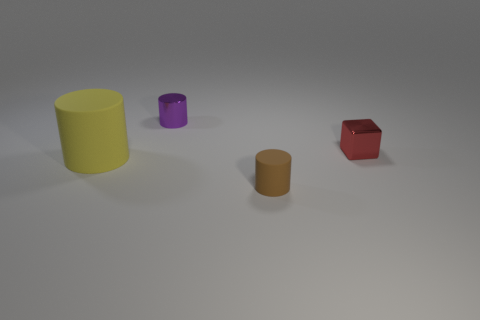Are there any other things that have the same size as the yellow matte cylinder?
Your response must be concise. No. There is a shiny object that is left of the rubber cylinder on the right side of the purple shiny cylinder; what color is it?
Your answer should be very brief. Purple. Are there any other large matte things of the same color as the large thing?
Offer a very short reply. No. There is a metallic object behind the metallic thing in front of the tiny shiny thing that is behind the tiny block; what size is it?
Your response must be concise. Small. There is a big yellow matte thing; is its shape the same as the small shiny object that is to the left of the small brown rubber object?
Keep it short and to the point. Yes. What number of other things are the same size as the brown thing?
Offer a very short reply. 2. What size is the purple cylinder that is to the left of the red object?
Keep it short and to the point. Small. What number of other cylinders are made of the same material as the large cylinder?
Keep it short and to the point. 1. There is a matte object that is in front of the yellow cylinder; is its shape the same as the yellow matte thing?
Ensure brevity in your answer.  Yes. There is a small metal object in front of the small metal cylinder; what shape is it?
Provide a succinct answer. Cube. 